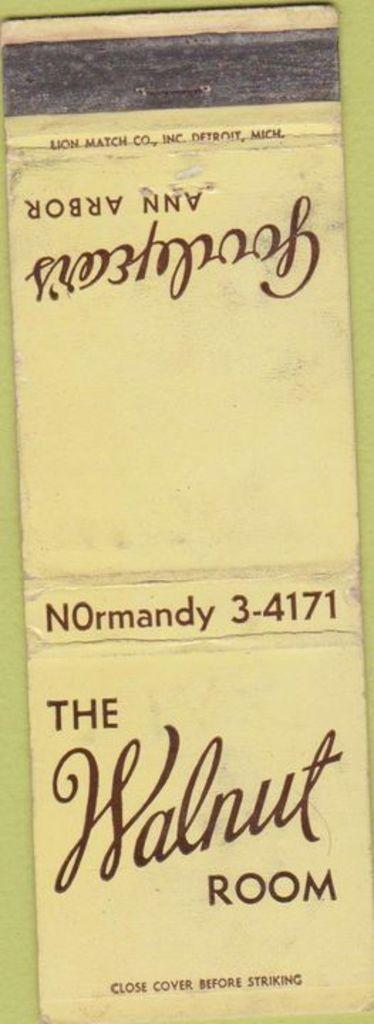<image>
Summarize the visual content of the image. A matchbook from The Walnut Room instructs people to close the cover before striking a match. 